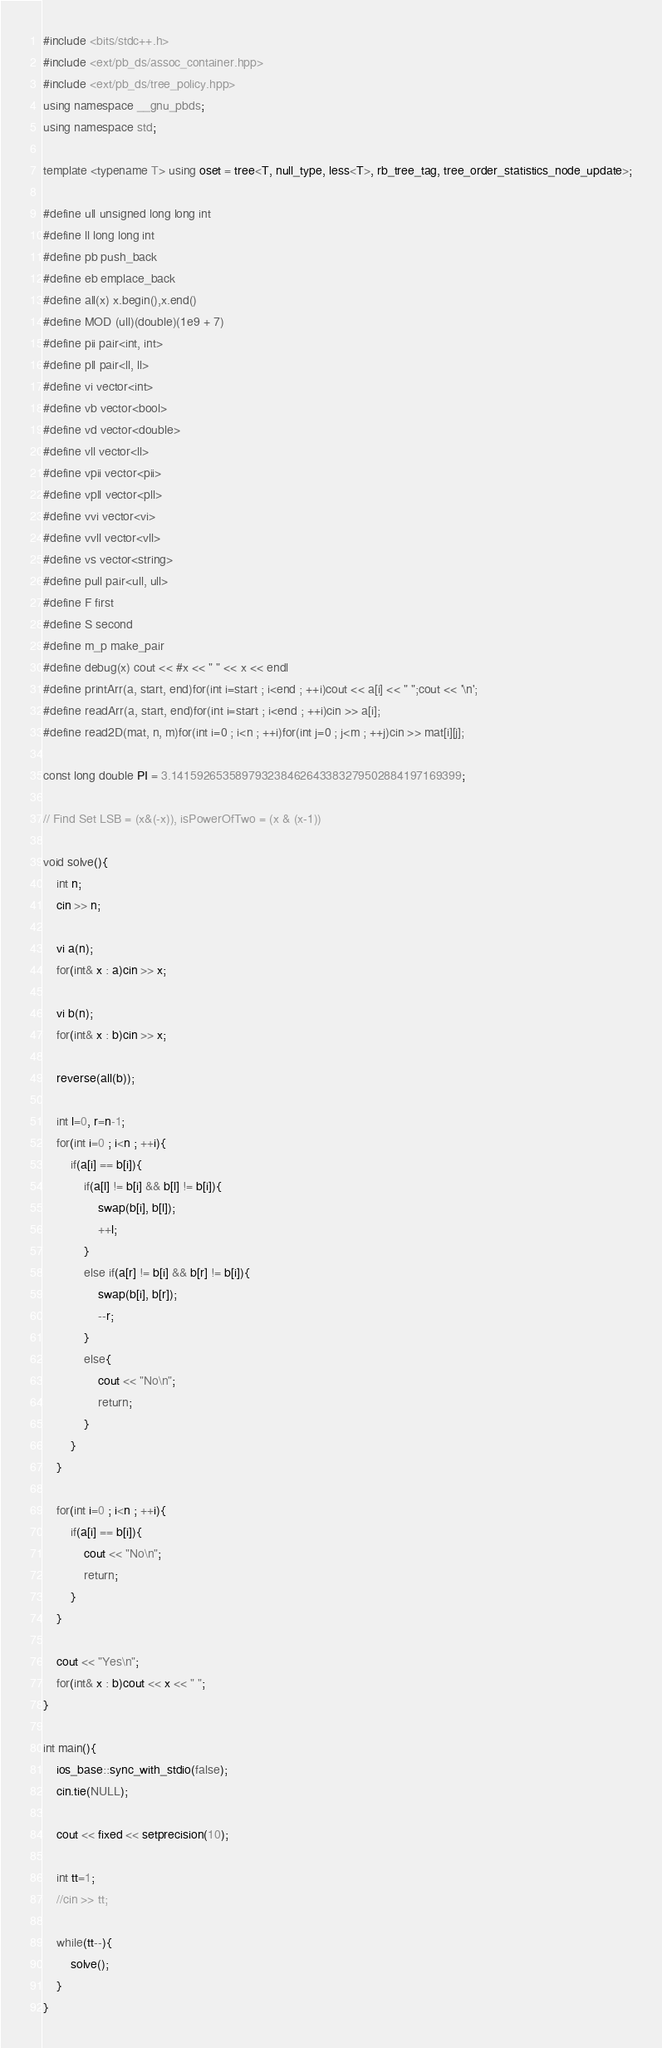<code> <loc_0><loc_0><loc_500><loc_500><_C++_>#include <bits/stdc++.h>
#include <ext/pb_ds/assoc_container.hpp>
#include <ext/pb_ds/tree_policy.hpp>
using namespace __gnu_pbds;
using namespace std;

template <typename T> using oset = tree<T, null_type, less<T>, rb_tree_tag, tree_order_statistics_node_update>;

#define ull unsigned long long int
#define ll long long int
#define pb push_back
#define eb emplace_back
#define all(x) x.begin(),x.end()
#define MOD (ull)(double)(1e9 + 7)
#define pii pair<int, int>
#define pll pair<ll, ll>
#define vi vector<int>
#define vb vector<bool>
#define vd vector<double>
#define vll vector<ll>
#define vpii vector<pii>
#define vpll vector<pll>
#define vvi vector<vi>
#define vvll vector<vll>
#define vs vector<string>
#define pull pair<ull, ull>
#define F first
#define S second
#define m_p make_pair
#define debug(x) cout << #x << " " << x << endl
#define printArr(a, start, end)for(int i=start ; i<end ; ++i)cout << a[i] << " ";cout << '\n';
#define readArr(a, start, end)for(int i=start ; i<end ; ++i)cin >> a[i];
#define read2D(mat, n, m)for(int i=0 ; i<n ; ++i)for(int j=0 ; j<m ; ++j)cin >> mat[i][j];

const long double PI = 3.141592653589793238462643383279502884197169399;

// Find Set LSB = (x&(-x)), isPowerOfTwo = (x & (x-1))

void solve(){
	int n;
	cin >> n;
	
	vi a(n);
	for(int& x : a)cin >> x;
	
	vi b(n);
	for(int& x : b)cin >> x;
	
	reverse(all(b));
	
	int l=0, r=n-1;
	for(int i=0 ; i<n ; ++i){
		if(a[i] == b[i]){
			if(a[l] != b[i] && b[l] != b[i]){
				swap(b[i], b[l]);
				++l;
			}
			else if(a[r] != b[i] && b[r] != b[i]){
				swap(b[i], b[r]);
				--r;
			}
			else{
				cout << "No\n";
				return;
			}
		}
	}
	
	for(int i=0 ; i<n ; ++i){
		if(a[i] == b[i]){
			cout << "No\n";
			return;
		}
	}
	
	cout << "Yes\n";
	for(int& x : b)cout << x << " ";
}

int main(){
	ios_base::sync_with_stdio(false);
	cin.tie(NULL);
	
	cout << fixed << setprecision(10);
	
	int tt=1;
	//cin >> tt;
	
	while(tt--){
		solve();
	}
}
</code> 